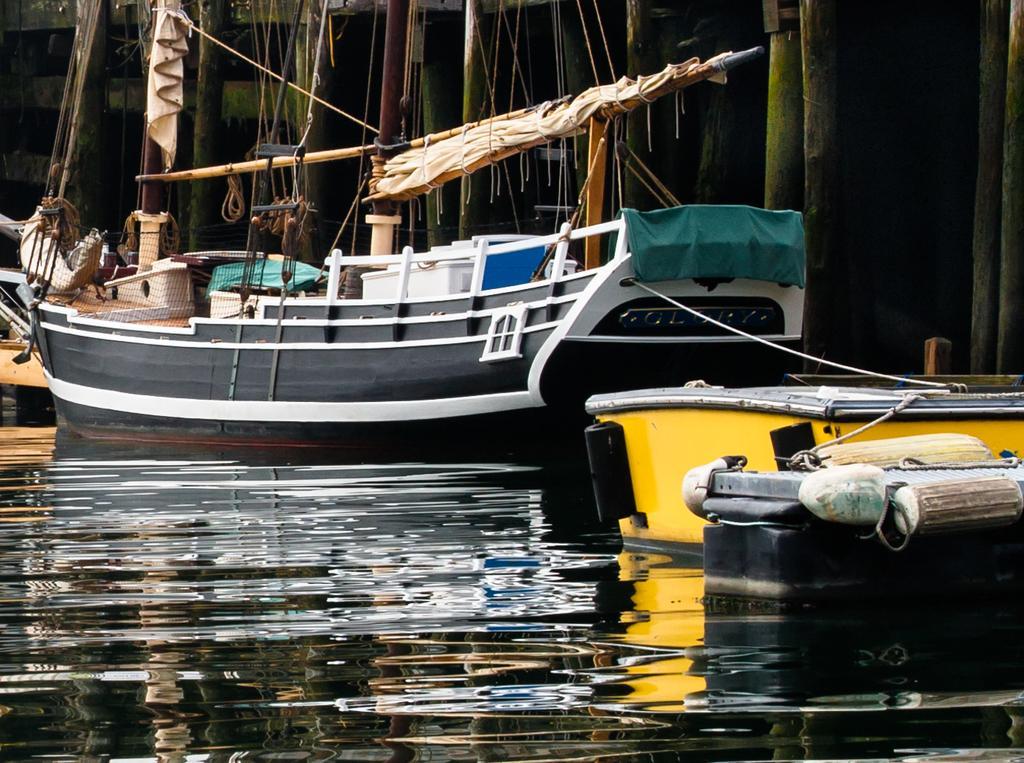In one or two sentences, can you explain what this image depicts? In this image we can see boats on the surface of water. One boat is in yellow color and the other one is in black and white color. Background of the image, bamboo poles are there. 